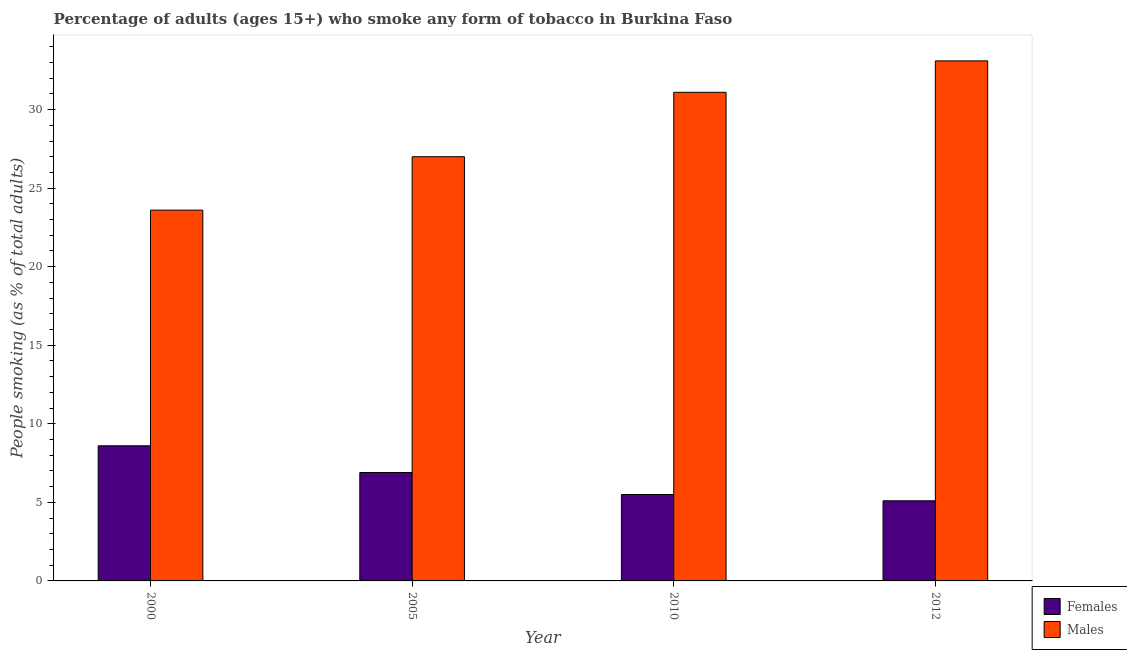How many different coloured bars are there?
Provide a succinct answer. 2. How many groups of bars are there?
Provide a succinct answer. 4. Are the number of bars on each tick of the X-axis equal?
Offer a very short reply. Yes. In how many cases, is the number of bars for a given year not equal to the number of legend labels?
Make the answer very short. 0. Across all years, what is the minimum percentage of females who smoke?
Make the answer very short. 5.1. What is the total percentage of females who smoke in the graph?
Ensure brevity in your answer.  26.1. What is the difference between the percentage of females who smoke in 2000 and that in 2005?
Make the answer very short. 1.7. What is the difference between the percentage of males who smoke in 2010 and the percentage of females who smoke in 2000?
Keep it short and to the point. 7.5. What is the average percentage of males who smoke per year?
Your answer should be very brief. 28.7. In how many years, is the percentage of females who smoke greater than 1 %?
Ensure brevity in your answer.  4. What is the ratio of the percentage of females who smoke in 2000 to that in 2010?
Offer a terse response. 1.56. What does the 1st bar from the left in 2000 represents?
Make the answer very short. Females. What does the 1st bar from the right in 2005 represents?
Offer a very short reply. Males. Are all the bars in the graph horizontal?
Provide a succinct answer. No. What is the difference between two consecutive major ticks on the Y-axis?
Provide a short and direct response. 5. Does the graph contain any zero values?
Provide a succinct answer. No. Where does the legend appear in the graph?
Offer a terse response. Bottom right. How are the legend labels stacked?
Offer a very short reply. Vertical. What is the title of the graph?
Your response must be concise. Percentage of adults (ages 15+) who smoke any form of tobacco in Burkina Faso. Does "Mineral" appear as one of the legend labels in the graph?
Provide a short and direct response. No. What is the label or title of the X-axis?
Your response must be concise. Year. What is the label or title of the Y-axis?
Your response must be concise. People smoking (as % of total adults). What is the People smoking (as % of total adults) of Females in 2000?
Your response must be concise. 8.6. What is the People smoking (as % of total adults) of Males in 2000?
Provide a short and direct response. 23.6. What is the People smoking (as % of total adults) in Females in 2010?
Provide a succinct answer. 5.5. What is the People smoking (as % of total adults) of Males in 2010?
Ensure brevity in your answer.  31.1. What is the People smoking (as % of total adults) in Females in 2012?
Keep it short and to the point. 5.1. What is the People smoking (as % of total adults) in Males in 2012?
Your answer should be very brief. 33.1. Across all years, what is the maximum People smoking (as % of total adults) of Males?
Ensure brevity in your answer.  33.1. Across all years, what is the minimum People smoking (as % of total adults) of Males?
Your answer should be compact. 23.6. What is the total People smoking (as % of total adults) of Females in the graph?
Your response must be concise. 26.1. What is the total People smoking (as % of total adults) in Males in the graph?
Offer a very short reply. 114.8. What is the difference between the People smoking (as % of total adults) of Females in 2000 and that in 2005?
Your response must be concise. 1.7. What is the difference between the People smoking (as % of total adults) of Females in 2000 and that in 2010?
Offer a terse response. 3.1. What is the difference between the People smoking (as % of total adults) in Males in 2000 and that in 2010?
Provide a succinct answer. -7.5. What is the difference between the People smoking (as % of total adults) of Females in 2000 and that in 2012?
Keep it short and to the point. 3.5. What is the difference between the People smoking (as % of total adults) in Females in 2005 and that in 2010?
Provide a succinct answer. 1.4. What is the difference between the People smoking (as % of total adults) in Females in 2005 and that in 2012?
Your answer should be compact. 1.8. What is the difference between the People smoking (as % of total adults) of Females in 2010 and that in 2012?
Offer a very short reply. 0.4. What is the difference between the People smoking (as % of total adults) in Females in 2000 and the People smoking (as % of total adults) in Males in 2005?
Offer a very short reply. -18.4. What is the difference between the People smoking (as % of total adults) of Females in 2000 and the People smoking (as % of total adults) of Males in 2010?
Provide a succinct answer. -22.5. What is the difference between the People smoking (as % of total adults) in Females in 2000 and the People smoking (as % of total adults) in Males in 2012?
Offer a very short reply. -24.5. What is the difference between the People smoking (as % of total adults) in Females in 2005 and the People smoking (as % of total adults) in Males in 2010?
Your response must be concise. -24.2. What is the difference between the People smoking (as % of total adults) in Females in 2005 and the People smoking (as % of total adults) in Males in 2012?
Give a very brief answer. -26.2. What is the difference between the People smoking (as % of total adults) in Females in 2010 and the People smoking (as % of total adults) in Males in 2012?
Your answer should be very brief. -27.6. What is the average People smoking (as % of total adults) of Females per year?
Your response must be concise. 6.53. What is the average People smoking (as % of total adults) of Males per year?
Keep it short and to the point. 28.7. In the year 2005, what is the difference between the People smoking (as % of total adults) in Females and People smoking (as % of total adults) in Males?
Your response must be concise. -20.1. In the year 2010, what is the difference between the People smoking (as % of total adults) of Females and People smoking (as % of total adults) of Males?
Your answer should be very brief. -25.6. What is the ratio of the People smoking (as % of total adults) of Females in 2000 to that in 2005?
Your answer should be compact. 1.25. What is the ratio of the People smoking (as % of total adults) in Males in 2000 to that in 2005?
Provide a short and direct response. 0.87. What is the ratio of the People smoking (as % of total adults) in Females in 2000 to that in 2010?
Offer a terse response. 1.56. What is the ratio of the People smoking (as % of total adults) of Males in 2000 to that in 2010?
Make the answer very short. 0.76. What is the ratio of the People smoking (as % of total adults) of Females in 2000 to that in 2012?
Provide a short and direct response. 1.69. What is the ratio of the People smoking (as % of total adults) of Males in 2000 to that in 2012?
Keep it short and to the point. 0.71. What is the ratio of the People smoking (as % of total adults) in Females in 2005 to that in 2010?
Provide a short and direct response. 1.25. What is the ratio of the People smoking (as % of total adults) in Males in 2005 to that in 2010?
Your answer should be very brief. 0.87. What is the ratio of the People smoking (as % of total adults) in Females in 2005 to that in 2012?
Keep it short and to the point. 1.35. What is the ratio of the People smoking (as % of total adults) in Males in 2005 to that in 2012?
Make the answer very short. 0.82. What is the ratio of the People smoking (as % of total adults) in Females in 2010 to that in 2012?
Your answer should be very brief. 1.08. What is the ratio of the People smoking (as % of total adults) in Males in 2010 to that in 2012?
Your answer should be compact. 0.94. What is the difference between the highest and the second highest People smoking (as % of total adults) of Females?
Your answer should be compact. 1.7. What is the difference between the highest and the lowest People smoking (as % of total adults) in Females?
Keep it short and to the point. 3.5. 